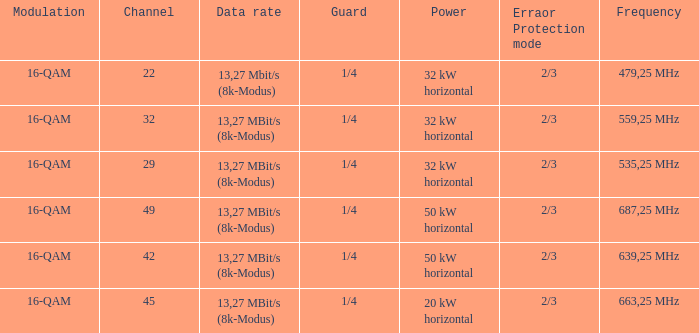At 32 kw horizontal power on channel 32, what frequency is it operating at? 559,25 MHz. Can you give me this table as a dict? {'header': ['Modulation', 'Channel', 'Data rate', 'Guard', 'Power', 'Erraor Protection mode', 'Frequency'], 'rows': [['16-QAM', '22', '13,27 Mbit/s (8k-Modus)', '1/4', '32 kW horizontal', '2/3', '479,25 MHz'], ['16-QAM', '32', '13,27 MBit/s (8k-Modus)', '1/4', '32 kW horizontal', '2/3', '559,25 MHz'], ['16-QAM', '29', '13,27 MBit/s (8k-Modus)', '1/4', '32 kW horizontal', '2/3', '535,25 MHz'], ['16-QAM', '49', '13,27 MBit/s (8k-Modus)', '1/4', '50 kW horizontal', '2/3', '687,25 MHz'], ['16-QAM', '42', '13,27 MBit/s (8k-Modus)', '1/4', '50 kW horizontal', '2/3', '639,25 MHz'], ['16-QAM', '45', '13,27 MBit/s (8k-Modus)', '1/4', '20 kW horizontal', '2/3', '663,25 MHz']]} 